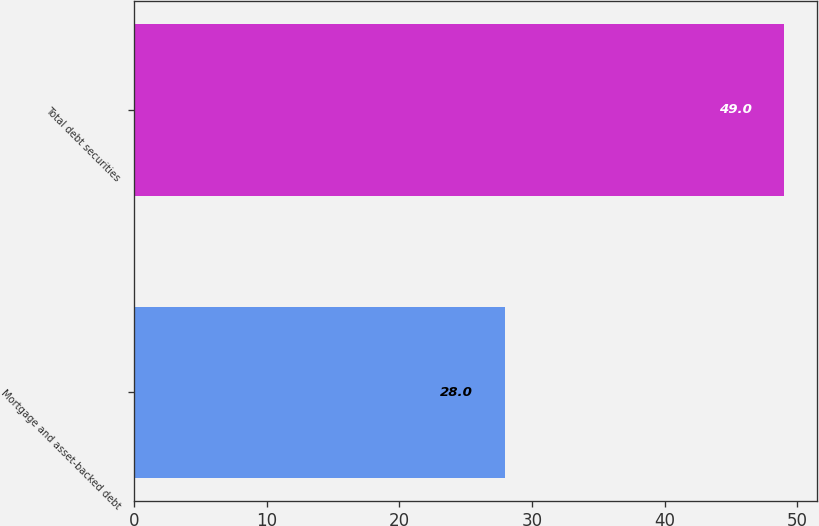Convert chart to OTSL. <chart><loc_0><loc_0><loc_500><loc_500><bar_chart><fcel>Mortgage and asset-backed debt<fcel>Total debt securities<nl><fcel>28<fcel>49<nl></chart> 